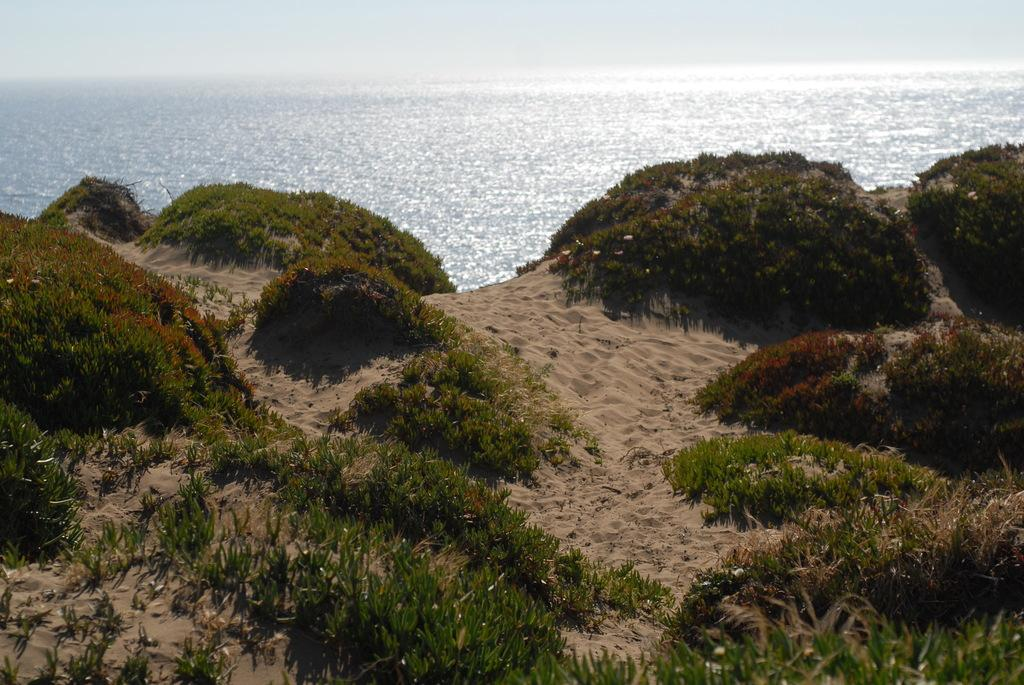What type of vegetation is present in the front of the image? There is grass and plants in the front of the image. What can be seen in the background of the image? There is an ocean visible in the background of the image. What type of shoes are visible in the image? There are no shoes present in the image. What emotion is the grass feeling in the image? Grass does not have emotions, so it cannot be feeling fear or any other emotion. 